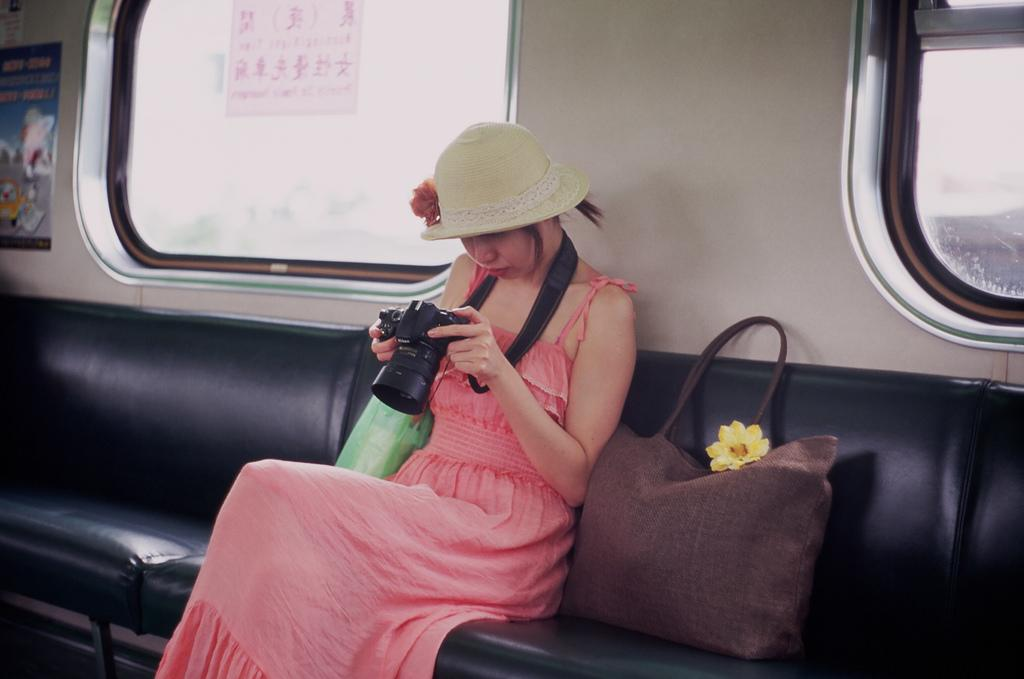Who is the main subject in the image? There is a girl in the image. What is the girl wearing? The girl is wearing a red dress. What is the girl holding in the image? The girl is holding a black camera. Where is the girl sitting? The girl is sitting in a train. What is located beside the girl? There is a brown bag beside the girl. What can be seen behind the girl? There is a train window behind the girl. What type of fireman is standing next to the girl in the image? There is no fireman present in the image; the girl is sitting in a train. What color is the flag that the girl is holding in the image? The girl is holding a black camera, not a flag, in the image. 